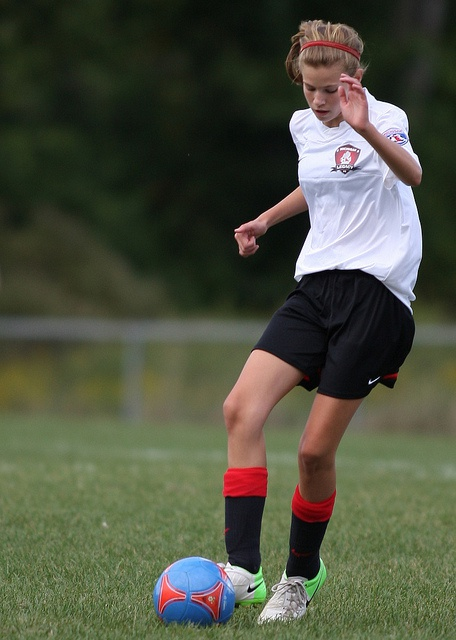Describe the objects in this image and their specific colors. I can see people in black, lavender, brown, and gray tones and sports ball in black, lightblue, blue, gray, and navy tones in this image. 